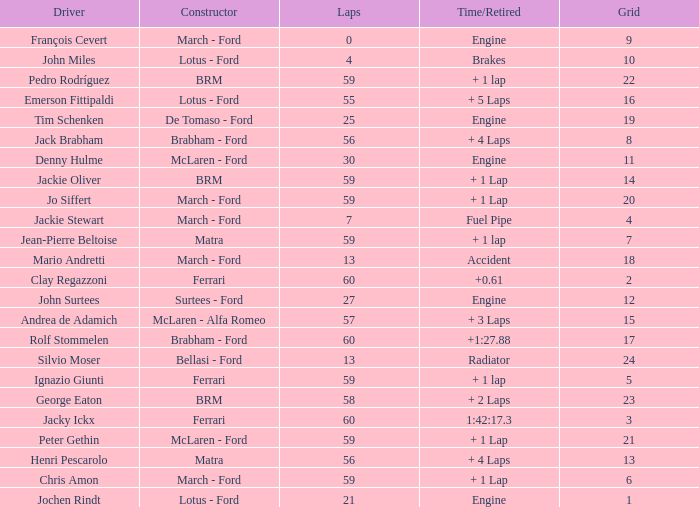I want the driver for grid of 9 François Cevert. 